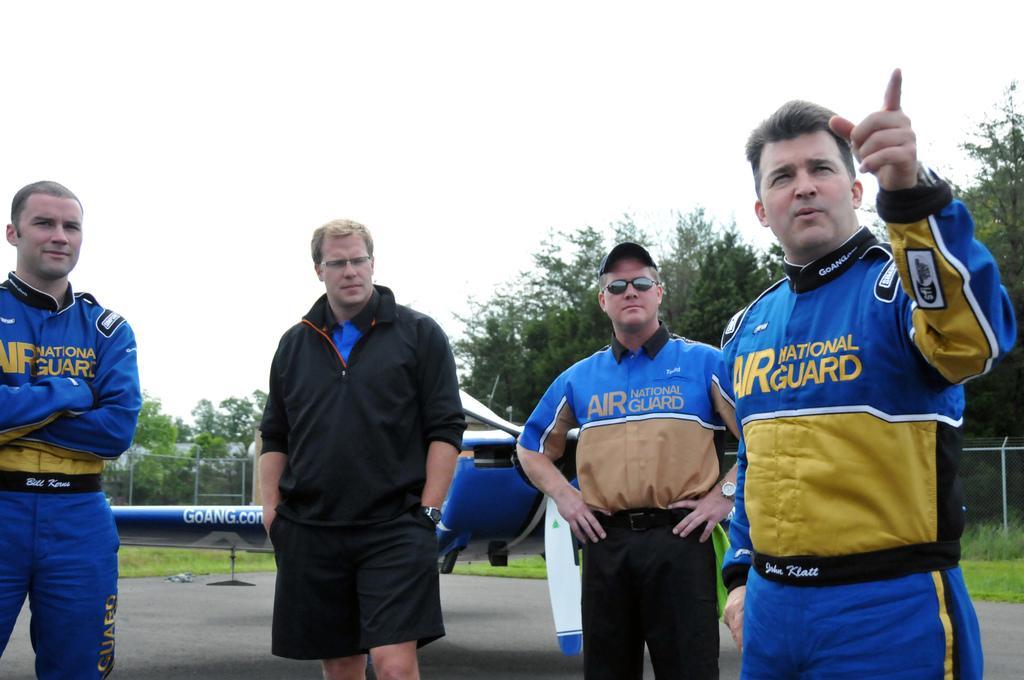Please provide a concise description of this image. As we can see in the image in the front there are four persons standing. There is a blue color plane, fence, grass and trees. At the top there is sky. 